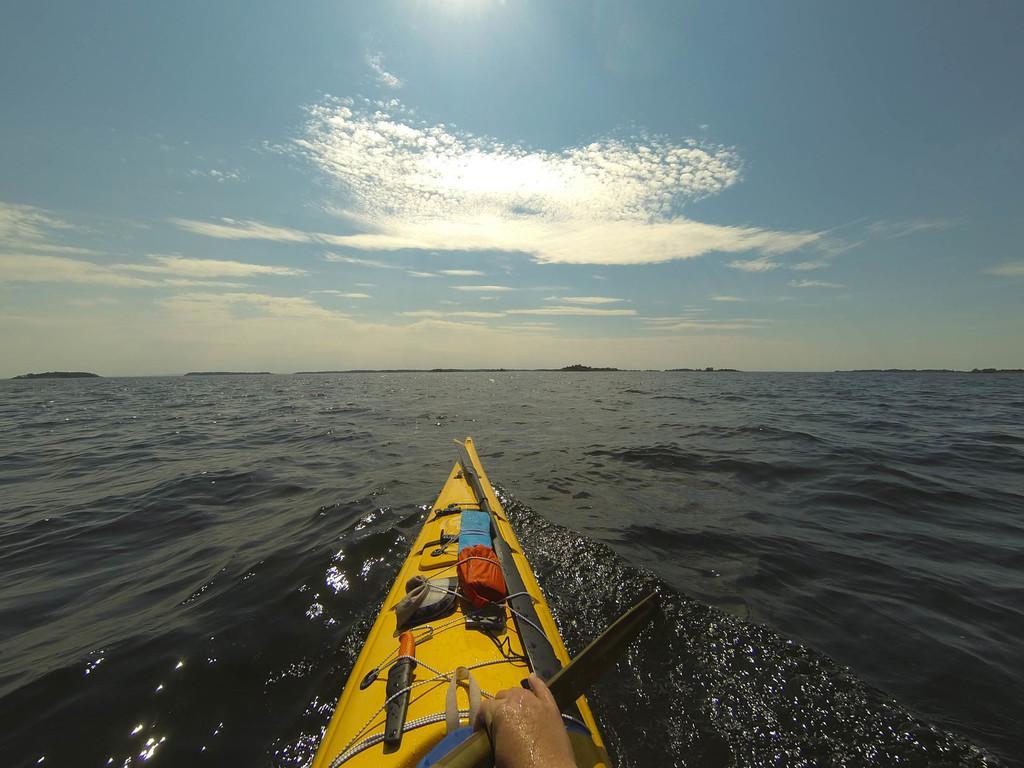Could you give a brief overview of what you see in this image? In the image there is a sea kayak sailing on the water surface and there is a hand of a person visible in the picture. 